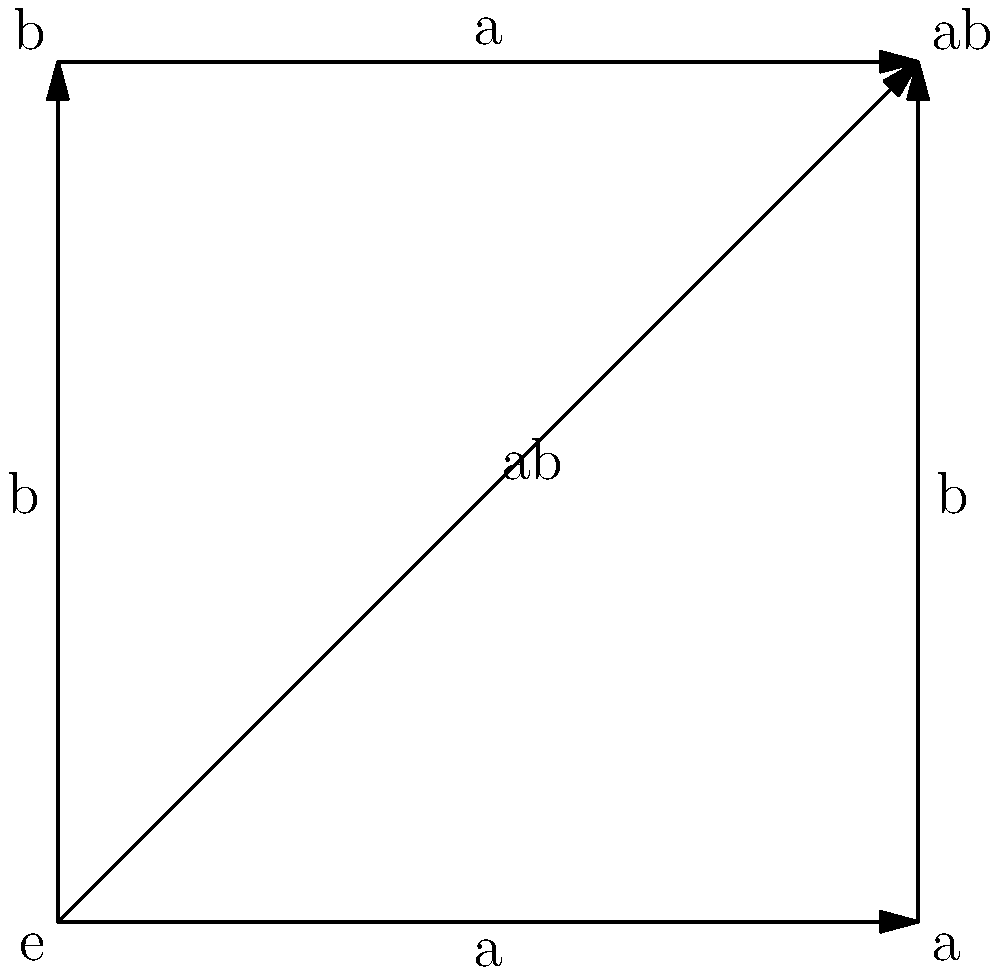Consider the Cayley graph of a group shown above. What is the order of the group, and what is the group isomorphic to? To determine the order and isomorphism class of the group, we'll follow these steps:

1. Count the number of vertices:
   There are 4 vertices: e, a, b, and ab.
   The order of the group is equal to the number of vertices, so the order is 4.

2. Identify the generators:
   The graph shows two generators: a and b.

3. Analyze the relations between generators:
   - a² = e (applying a twice returns to e)
   - b² = e (applying b twice returns to e)
   - ab = ba (commutative property, as there's a single vertex labeled ab)

4. Recognize the group structure:
   The group has two elements of order 2 (a and b) that commute with each other.

5. Identify the isomorphism:
   This structure is isomorphic to the Klein four-group, also known as V₄ or C₂ × C₂ (the direct product of two cyclic groups of order 2).

Therefore, the group is of order 4 and is isomorphic to the Klein four-group.
Answer: Order 4, isomorphic to Klein four-group (V₄ or C₂ × C₂) 